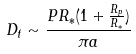Convert formula to latex. <formula><loc_0><loc_0><loc_500><loc_500>D _ { t } \sim \frac { P R _ { * } ( 1 + \frac { R _ { p } } { R _ { * } } ) } { \pi a }</formula> 